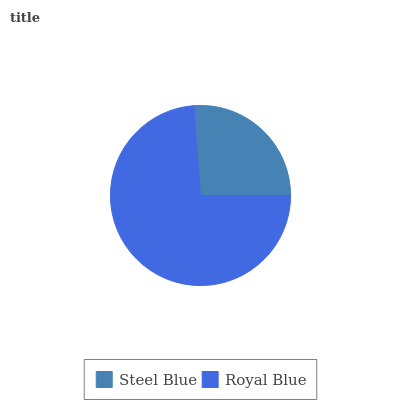Is Steel Blue the minimum?
Answer yes or no. Yes. Is Royal Blue the maximum?
Answer yes or no. Yes. Is Royal Blue the minimum?
Answer yes or no. No. Is Royal Blue greater than Steel Blue?
Answer yes or no. Yes. Is Steel Blue less than Royal Blue?
Answer yes or no. Yes. Is Steel Blue greater than Royal Blue?
Answer yes or no. No. Is Royal Blue less than Steel Blue?
Answer yes or no. No. Is Royal Blue the high median?
Answer yes or no. Yes. Is Steel Blue the low median?
Answer yes or no. Yes. Is Steel Blue the high median?
Answer yes or no. No. Is Royal Blue the low median?
Answer yes or no. No. 